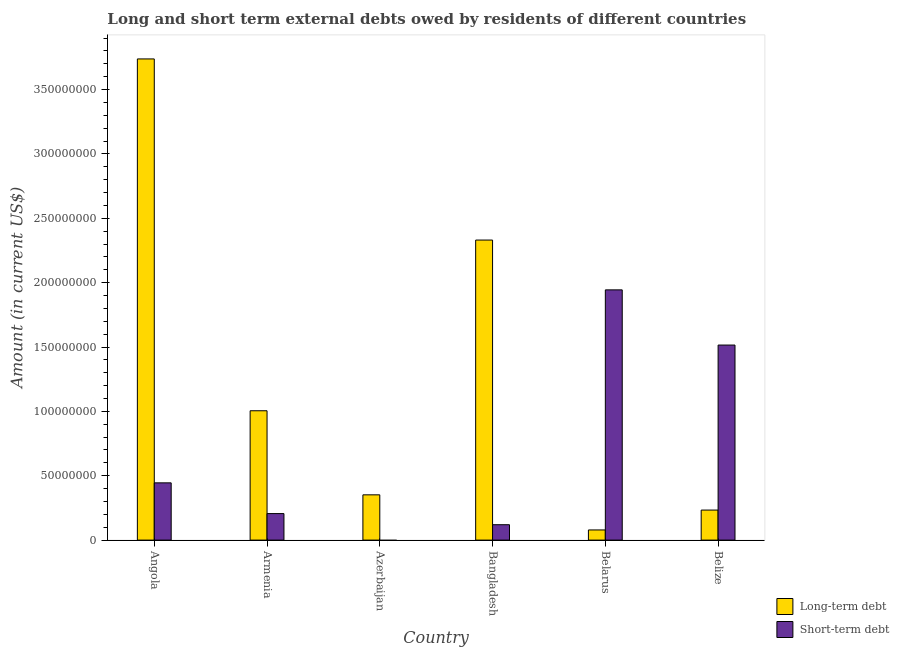Are the number of bars per tick equal to the number of legend labels?
Ensure brevity in your answer.  No. How many bars are there on the 6th tick from the left?
Offer a terse response. 2. How many bars are there on the 6th tick from the right?
Ensure brevity in your answer.  2. Across all countries, what is the maximum long-term debts owed by residents?
Provide a succinct answer. 3.74e+08. Across all countries, what is the minimum short-term debts owed by residents?
Make the answer very short. 0. In which country was the short-term debts owed by residents maximum?
Offer a very short reply. Belarus. What is the total short-term debts owed by residents in the graph?
Provide a short and direct response. 4.23e+08. What is the difference between the long-term debts owed by residents in Angola and that in Belarus?
Provide a short and direct response. 3.66e+08. What is the difference between the long-term debts owed by residents in Angola and the short-term debts owed by residents in Belize?
Your answer should be very brief. 2.22e+08. What is the average short-term debts owed by residents per country?
Offer a terse response. 7.05e+07. What is the difference between the long-term debts owed by residents and short-term debts owed by residents in Bangladesh?
Make the answer very short. 2.21e+08. What is the ratio of the long-term debts owed by residents in Armenia to that in Bangladesh?
Ensure brevity in your answer.  0.43. What is the difference between the highest and the second highest short-term debts owed by residents?
Make the answer very short. 4.29e+07. What is the difference between the highest and the lowest short-term debts owed by residents?
Keep it short and to the point. 1.94e+08. Is the sum of the long-term debts owed by residents in Armenia and Azerbaijan greater than the maximum short-term debts owed by residents across all countries?
Your response must be concise. No. How many bars are there?
Provide a short and direct response. 11. Are all the bars in the graph horizontal?
Your answer should be compact. No. How many countries are there in the graph?
Give a very brief answer. 6. What is the difference between two consecutive major ticks on the Y-axis?
Keep it short and to the point. 5.00e+07. Where does the legend appear in the graph?
Ensure brevity in your answer.  Bottom right. How many legend labels are there?
Offer a very short reply. 2. What is the title of the graph?
Give a very brief answer. Long and short term external debts owed by residents of different countries. What is the Amount (in current US$) in Long-term debt in Angola?
Keep it short and to the point. 3.74e+08. What is the Amount (in current US$) in Short-term debt in Angola?
Your answer should be very brief. 4.45e+07. What is the Amount (in current US$) in Long-term debt in Armenia?
Your response must be concise. 1.00e+08. What is the Amount (in current US$) of Short-term debt in Armenia?
Your response must be concise. 2.06e+07. What is the Amount (in current US$) of Long-term debt in Azerbaijan?
Make the answer very short. 3.52e+07. What is the Amount (in current US$) of Short-term debt in Azerbaijan?
Your response must be concise. 0. What is the Amount (in current US$) of Long-term debt in Bangladesh?
Ensure brevity in your answer.  2.33e+08. What is the Amount (in current US$) of Short-term debt in Bangladesh?
Make the answer very short. 1.20e+07. What is the Amount (in current US$) in Long-term debt in Belarus?
Offer a terse response. 7.89e+06. What is the Amount (in current US$) in Short-term debt in Belarus?
Your answer should be very brief. 1.94e+08. What is the Amount (in current US$) in Long-term debt in Belize?
Ensure brevity in your answer.  2.33e+07. What is the Amount (in current US$) in Short-term debt in Belize?
Make the answer very short. 1.52e+08. Across all countries, what is the maximum Amount (in current US$) in Long-term debt?
Your answer should be very brief. 3.74e+08. Across all countries, what is the maximum Amount (in current US$) of Short-term debt?
Your response must be concise. 1.94e+08. Across all countries, what is the minimum Amount (in current US$) of Long-term debt?
Keep it short and to the point. 7.89e+06. What is the total Amount (in current US$) in Long-term debt in the graph?
Ensure brevity in your answer.  7.74e+08. What is the total Amount (in current US$) in Short-term debt in the graph?
Your answer should be compact. 4.23e+08. What is the difference between the Amount (in current US$) in Long-term debt in Angola and that in Armenia?
Keep it short and to the point. 2.73e+08. What is the difference between the Amount (in current US$) in Short-term debt in Angola and that in Armenia?
Keep it short and to the point. 2.39e+07. What is the difference between the Amount (in current US$) in Long-term debt in Angola and that in Azerbaijan?
Provide a succinct answer. 3.39e+08. What is the difference between the Amount (in current US$) of Long-term debt in Angola and that in Bangladesh?
Your response must be concise. 1.41e+08. What is the difference between the Amount (in current US$) in Short-term debt in Angola and that in Bangladesh?
Keep it short and to the point. 3.25e+07. What is the difference between the Amount (in current US$) of Long-term debt in Angola and that in Belarus?
Ensure brevity in your answer.  3.66e+08. What is the difference between the Amount (in current US$) in Short-term debt in Angola and that in Belarus?
Ensure brevity in your answer.  -1.50e+08. What is the difference between the Amount (in current US$) in Long-term debt in Angola and that in Belize?
Offer a terse response. 3.50e+08. What is the difference between the Amount (in current US$) of Short-term debt in Angola and that in Belize?
Keep it short and to the point. -1.07e+08. What is the difference between the Amount (in current US$) of Long-term debt in Armenia and that in Azerbaijan?
Offer a very short reply. 6.53e+07. What is the difference between the Amount (in current US$) in Long-term debt in Armenia and that in Bangladesh?
Make the answer very short. -1.33e+08. What is the difference between the Amount (in current US$) of Short-term debt in Armenia and that in Bangladesh?
Your answer should be very brief. 8.64e+06. What is the difference between the Amount (in current US$) in Long-term debt in Armenia and that in Belarus?
Your answer should be compact. 9.26e+07. What is the difference between the Amount (in current US$) in Short-term debt in Armenia and that in Belarus?
Ensure brevity in your answer.  -1.74e+08. What is the difference between the Amount (in current US$) of Long-term debt in Armenia and that in Belize?
Ensure brevity in your answer.  7.71e+07. What is the difference between the Amount (in current US$) in Short-term debt in Armenia and that in Belize?
Your answer should be compact. -1.31e+08. What is the difference between the Amount (in current US$) of Long-term debt in Azerbaijan and that in Bangladesh?
Give a very brief answer. -1.98e+08. What is the difference between the Amount (in current US$) in Long-term debt in Azerbaijan and that in Belarus?
Provide a short and direct response. 2.73e+07. What is the difference between the Amount (in current US$) in Long-term debt in Azerbaijan and that in Belize?
Your response must be concise. 1.18e+07. What is the difference between the Amount (in current US$) of Long-term debt in Bangladesh and that in Belarus?
Offer a very short reply. 2.25e+08. What is the difference between the Amount (in current US$) in Short-term debt in Bangladesh and that in Belarus?
Keep it short and to the point. -1.82e+08. What is the difference between the Amount (in current US$) of Long-term debt in Bangladesh and that in Belize?
Keep it short and to the point. 2.10e+08. What is the difference between the Amount (in current US$) of Short-term debt in Bangladesh and that in Belize?
Provide a succinct answer. -1.40e+08. What is the difference between the Amount (in current US$) of Long-term debt in Belarus and that in Belize?
Offer a terse response. -1.54e+07. What is the difference between the Amount (in current US$) of Short-term debt in Belarus and that in Belize?
Your response must be concise. 4.29e+07. What is the difference between the Amount (in current US$) of Long-term debt in Angola and the Amount (in current US$) of Short-term debt in Armenia?
Make the answer very short. 3.53e+08. What is the difference between the Amount (in current US$) in Long-term debt in Angola and the Amount (in current US$) in Short-term debt in Bangladesh?
Your response must be concise. 3.62e+08. What is the difference between the Amount (in current US$) in Long-term debt in Angola and the Amount (in current US$) in Short-term debt in Belarus?
Give a very brief answer. 1.79e+08. What is the difference between the Amount (in current US$) in Long-term debt in Angola and the Amount (in current US$) in Short-term debt in Belize?
Your answer should be very brief. 2.22e+08. What is the difference between the Amount (in current US$) of Long-term debt in Armenia and the Amount (in current US$) of Short-term debt in Bangladesh?
Provide a short and direct response. 8.85e+07. What is the difference between the Amount (in current US$) of Long-term debt in Armenia and the Amount (in current US$) of Short-term debt in Belarus?
Provide a short and direct response. -9.39e+07. What is the difference between the Amount (in current US$) in Long-term debt in Armenia and the Amount (in current US$) in Short-term debt in Belize?
Offer a very short reply. -5.10e+07. What is the difference between the Amount (in current US$) of Long-term debt in Azerbaijan and the Amount (in current US$) of Short-term debt in Bangladesh?
Offer a terse response. 2.32e+07. What is the difference between the Amount (in current US$) in Long-term debt in Azerbaijan and the Amount (in current US$) in Short-term debt in Belarus?
Provide a short and direct response. -1.59e+08. What is the difference between the Amount (in current US$) in Long-term debt in Azerbaijan and the Amount (in current US$) in Short-term debt in Belize?
Provide a succinct answer. -1.16e+08. What is the difference between the Amount (in current US$) of Long-term debt in Bangladesh and the Amount (in current US$) of Short-term debt in Belarus?
Give a very brief answer. 3.87e+07. What is the difference between the Amount (in current US$) of Long-term debt in Bangladesh and the Amount (in current US$) of Short-term debt in Belize?
Ensure brevity in your answer.  8.16e+07. What is the difference between the Amount (in current US$) in Long-term debt in Belarus and the Amount (in current US$) in Short-term debt in Belize?
Your answer should be compact. -1.44e+08. What is the average Amount (in current US$) of Long-term debt per country?
Ensure brevity in your answer.  1.29e+08. What is the average Amount (in current US$) of Short-term debt per country?
Provide a succinct answer. 7.05e+07. What is the difference between the Amount (in current US$) of Long-term debt and Amount (in current US$) of Short-term debt in Angola?
Offer a terse response. 3.29e+08. What is the difference between the Amount (in current US$) in Long-term debt and Amount (in current US$) in Short-term debt in Armenia?
Provide a short and direct response. 7.99e+07. What is the difference between the Amount (in current US$) in Long-term debt and Amount (in current US$) in Short-term debt in Bangladesh?
Your response must be concise. 2.21e+08. What is the difference between the Amount (in current US$) in Long-term debt and Amount (in current US$) in Short-term debt in Belarus?
Give a very brief answer. -1.87e+08. What is the difference between the Amount (in current US$) of Long-term debt and Amount (in current US$) of Short-term debt in Belize?
Give a very brief answer. -1.28e+08. What is the ratio of the Amount (in current US$) of Long-term debt in Angola to that in Armenia?
Your answer should be compact. 3.72. What is the ratio of the Amount (in current US$) in Short-term debt in Angola to that in Armenia?
Give a very brief answer. 2.16. What is the ratio of the Amount (in current US$) in Long-term debt in Angola to that in Azerbaijan?
Ensure brevity in your answer.  10.63. What is the ratio of the Amount (in current US$) of Long-term debt in Angola to that in Bangladesh?
Keep it short and to the point. 1.6. What is the ratio of the Amount (in current US$) of Short-term debt in Angola to that in Bangladesh?
Your answer should be very brief. 3.72. What is the ratio of the Amount (in current US$) in Long-term debt in Angola to that in Belarus?
Your response must be concise. 47.35. What is the ratio of the Amount (in current US$) of Short-term debt in Angola to that in Belarus?
Make the answer very short. 0.23. What is the ratio of the Amount (in current US$) of Long-term debt in Angola to that in Belize?
Keep it short and to the point. 16.02. What is the ratio of the Amount (in current US$) of Short-term debt in Angola to that in Belize?
Your answer should be very brief. 0.29. What is the ratio of the Amount (in current US$) in Long-term debt in Armenia to that in Azerbaijan?
Your answer should be compact. 2.86. What is the ratio of the Amount (in current US$) in Long-term debt in Armenia to that in Bangladesh?
Provide a short and direct response. 0.43. What is the ratio of the Amount (in current US$) in Short-term debt in Armenia to that in Bangladesh?
Provide a succinct answer. 1.72. What is the ratio of the Amount (in current US$) in Long-term debt in Armenia to that in Belarus?
Give a very brief answer. 12.73. What is the ratio of the Amount (in current US$) of Short-term debt in Armenia to that in Belarus?
Your response must be concise. 0.11. What is the ratio of the Amount (in current US$) in Long-term debt in Armenia to that in Belize?
Ensure brevity in your answer.  4.31. What is the ratio of the Amount (in current US$) in Short-term debt in Armenia to that in Belize?
Your response must be concise. 0.14. What is the ratio of the Amount (in current US$) in Long-term debt in Azerbaijan to that in Bangladesh?
Keep it short and to the point. 0.15. What is the ratio of the Amount (in current US$) in Long-term debt in Azerbaijan to that in Belarus?
Your answer should be compact. 4.45. What is the ratio of the Amount (in current US$) in Long-term debt in Azerbaijan to that in Belize?
Offer a terse response. 1.51. What is the ratio of the Amount (in current US$) of Long-term debt in Bangladesh to that in Belarus?
Keep it short and to the point. 29.53. What is the ratio of the Amount (in current US$) in Short-term debt in Bangladesh to that in Belarus?
Provide a short and direct response. 0.06. What is the ratio of the Amount (in current US$) of Long-term debt in Bangladesh to that in Belize?
Provide a succinct answer. 9.99. What is the ratio of the Amount (in current US$) of Short-term debt in Bangladesh to that in Belize?
Offer a very short reply. 0.08. What is the ratio of the Amount (in current US$) in Long-term debt in Belarus to that in Belize?
Give a very brief answer. 0.34. What is the ratio of the Amount (in current US$) in Short-term debt in Belarus to that in Belize?
Offer a terse response. 1.28. What is the difference between the highest and the second highest Amount (in current US$) in Long-term debt?
Ensure brevity in your answer.  1.41e+08. What is the difference between the highest and the second highest Amount (in current US$) of Short-term debt?
Give a very brief answer. 4.29e+07. What is the difference between the highest and the lowest Amount (in current US$) in Long-term debt?
Your answer should be compact. 3.66e+08. What is the difference between the highest and the lowest Amount (in current US$) in Short-term debt?
Provide a short and direct response. 1.94e+08. 